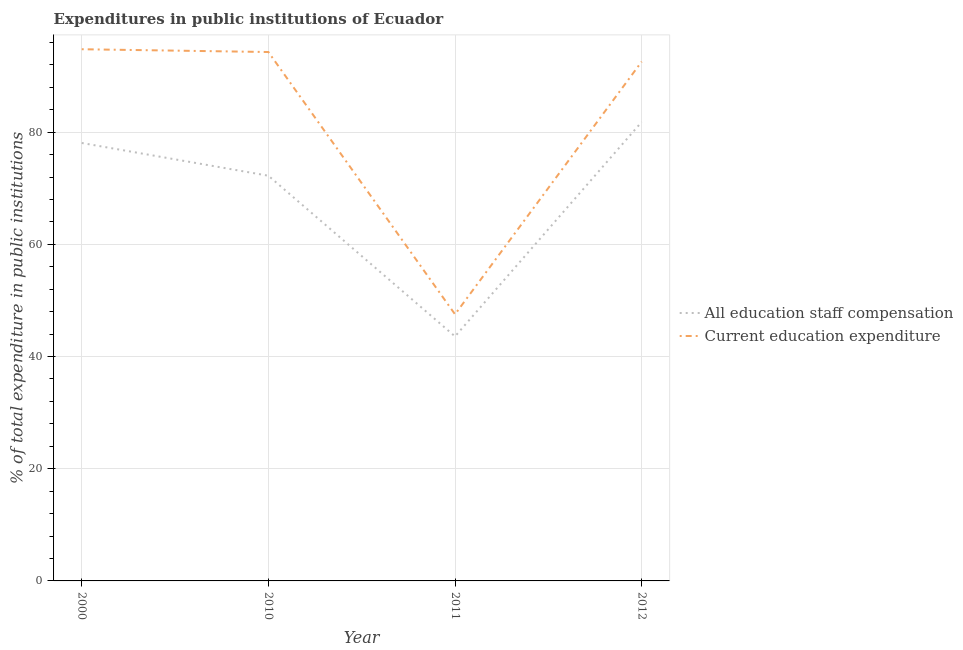Is the number of lines equal to the number of legend labels?
Ensure brevity in your answer.  Yes. What is the expenditure in education in 2000?
Provide a succinct answer. 94.78. Across all years, what is the maximum expenditure in education?
Ensure brevity in your answer.  94.78. Across all years, what is the minimum expenditure in staff compensation?
Ensure brevity in your answer.  43.59. What is the total expenditure in education in the graph?
Your answer should be compact. 329.16. What is the difference between the expenditure in education in 2000 and that in 2011?
Ensure brevity in your answer.  47.25. What is the difference between the expenditure in staff compensation in 2010 and the expenditure in education in 2011?
Your answer should be compact. 24.7. What is the average expenditure in staff compensation per year?
Offer a terse response. 68.93. In the year 2010, what is the difference between the expenditure in staff compensation and expenditure in education?
Offer a terse response. -22.05. In how many years, is the expenditure in staff compensation greater than 72 %?
Keep it short and to the point. 3. What is the ratio of the expenditure in staff compensation in 2000 to that in 2010?
Your answer should be compact. 1.08. Is the expenditure in education in 2000 less than that in 2010?
Give a very brief answer. No. What is the difference between the highest and the second highest expenditure in staff compensation?
Your answer should be very brief. 3.75. What is the difference between the highest and the lowest expenditure in education?
Ensure brevity in your answer.  47.25. In how many years, is the expenditure in staff compensation greater than the average expenditure in staff compensation taken over all years?
Provide a short and direct response. 3. Is the sum of the expenditure in education in 2000 and 2012 greater than the maximum expenditure in staff compensation across all years?
Your answer should be compact. Yes. Does the expenditure in education monotonically increase over the years?
Make the answer very short. No. Is the expenditure in staff compensation strictly greater than the expenditure in education over the years?
Your answer should be compact. No. Is the expenditure in staff compensation strictly less than the expenditure in education over the years?
Offer a terse response. Yes. What is the difference between two consecutive major ticks on the Y-axis?
Provide a succinct answer. 20. Does the graph contain any zero values?
Your response must be concise. No. Does the graph contain grids?
Give a very brief answer. Yes. How are the legend labels stacked?
Ensure brevity in your answer.  Vertical. What is the title of the graph?
Your response must be concise. Expenditures in public institutions of Ecuador. Does "Private credit bureau" appear as one of the legend labels in the graph?
Make the answer very short. No. What is the label or title of the X-axis?
Provide a succinct answer. Year. What is the label or title of the Y-axis?
Provide a short and direct response. % of total expenditure in public institutions. What is the % of total expenditure in public institutions of All education staff compensation in 2000?
Make the answer very short. 78.07. What is the % of total expenditure in public institutions in Current education expenditure in 2000?
Make the answer very short. 94.78. What is the % of total expenditure in public institutions of All education staff compensation in 2010?
Make the answer very short. 72.23. What is the % of total expenditure in public institutions in Current education expenditure in 2010?
Provide a succinct answer. 94.28. What is the % of total expenditure in public institutions in All education staff compensation in 2011?
Your answer should be very brief. 43.59. What is the % of total expenditure in public institutions of Current education expenditure in 2011?
Make the answer very short. 47.53. What is the % of total expenditure in public institutions in All education staff compensation in 2012?
Offer a very short reply. 81.82. What is the % of total expenditure in public institutions of Current education expenditure in 2012?
Your answer should be very brief. 92.57. Across all years, what is the maximum % of total expenditure in public institutions of All education staff compensation?
Your answer should be very brief. 81.82. Across all years, what is the maximum % of total expenditure in public institutions in Current education expenditure?
Give a very brief answer. 94.78. Across all years, what is the minimum % of total expenditure in public institutions of All education staff compensation?
Ensure brevity in your answer.  43.59. Across all years, what is the minimum % of total expenditure in public institutions of Current education expenditure?
Your answer should be very brief. 47.53. What is the total % of total expenditure in public institutions in All education staff compensation in the graph?
Provide a succinct answer. 275.71. What is the total % of total expenditure in public institutions in Current education expenditure in the graph?
Your answer should be compact. 329.16. What is the difference between the % of total expenditure in public institutions of All education staff compensation in 2000 and that in 2010?
Offer a terse response. 5.84. What is the difference between the % of total expenditure in public institutions of Current education expenditure in 2000 and that in 2010?
Provide a short and direct response. 0.5. What is the difference between the % of total expenditure in public institutions of All education staff compensation in 2000 and that in 2011?
Make the answer very short. 34.48. What is the difference between the % of total expenditure in public institutions of Current education expenditure in 2000 and that in 2011?
Ensure brevity in your answer.  47.25. What is the difference between the % of total expenditure in public institutions in All education staff compensation in 2000 and that in 2012?
Give a very brief answer. -3.75. What is the difference between the % of total expenditure in public institutions of Current education expenditure in 2000 and that in 2012?
Make the answer very short. 2.21. What is the difference between the % of total expenditure in public institutions of All education staff compensation in 2010 and that in 2011?
Provide a short and direct response. 28.64. What is the difference between the % of total expenditure in public institutions of Current education expenditure in 2010 and that in 2011?
Give a very brief answer. 46.75. What is the difference between the % of total expenditure in public institutions in All education staff compensation in 2010 and that in 2012?
Your response must be concise. -9.58. What is the difference between the % of total expenditure in public institutions of Current education expenditure in 2010 and that in 2012?
Ensure brevity in your answer.  1.71. What is the difference between the % of total expenditure in public institutions in All education staff compensation in 2011 and that in 2012?
Your answer should be compact. -38.23. What is the difference between the % of total expenditure in public institutions of Current education expenditure in 2011 and that in 2012?
Give a very brief answer. -45.04. What is the difference between the % of total expenditure in public institutions in All education staff compensation in 2000 and the % of total expenditure in public institutions in Current education expenditure in 2010?
Make the answer very short. -16.21. What is the difference between the % of total expenditure in public institutions in All education staff compensation in 2000 and the % of total expenditure in public institutions in Current education expenditure in 2011?
Provide a short and direct response. 30.54. What is the difference between the % of total expenditure in public institutions in All education staff compensation in 2000 and the % of total expenditure in public institutions in Current education expenditure in 2012?
Offer a terse response. -14.5. What is the difference between the % of total expenditure in public institutions in All education staff compensation in 2010 and the % of total expenditure in public institutions in Current education expenditure in 2011?
Your answer should be compact. 24.7. What is the difference between the % of total expenditure in public institutions in All education staff compensation in 2010 and the % of total expenditure in public institutions in Current education expenditure in 2012?
Your answer should be very brief. -20.34. What is the difference between the % of total expenditure in public institutions of All education staff compensation in 2011 and the % of total expenditure in public institutions of Current education expenditure in 2012?
Offer a very short reply. -48.98. What is the average % of total expenditure in public institutions in All education staff compensation per year?
Keep it short and to the point. 68.93. What is the average % of total expenditure in public institutions in Current education expenditure per year?
Offer a very short reply. 82.29. In the year 2000, what is the difference between the % of total expenditure in public institutions of All education staff compensation and % of total expenditure in public institutions of Current education expenditure?
Your answer should be very brief. -16.71. In the year 2010, what is the difference between the % of total expenditure in public institutions in All education staff compensation and % of total expenditure in public institutions in Current education expenditure?
Offer a terse response. -22.05. In the year 2011, what is the difference between the % of total expenditure in public institutions of All education staff compensation and % of total expenditure in public institutions of Current education expenditure?
Make the answer very short. -3.94. In the year 2012, what is the difference between the % of total expenditure in public institutions in All education staff compensation and % of total expenditure in public institutions in Current education expenditure?
Provide a short and direct response. -10.75. What is the ratio of the % of total expenditure in public institutions in All education staff compensation in 2000 to that in 2010?
Offer a very short reply. 1.08. What is the ratio of the % of total expenditure in public institutions of Current education expenditure in 2000 to that in 2010?
Your answer should be compact. 1.01. What is the ratio of the % of total expenditure in public institutions of All education staff compensation in 2000 to that in 2011?
Offer a very short reply. 1.79. What is the ratio of the % of total expenditure in public institutions of Current education expenditure in 2000 to that in 2011?
Offer a terse response. 1.99. What is the ratio of the % of total expenditure in public institutions in All education staff compensation in 2000 to that in 2012?
Give a very brief answer. 0.95. What is the ratio of the % of total expenditure in public institutions in Current education expenditure in 2000 to that in 2012?
Your answer should be compact. 1.02. What is the ratio of the % of total expenditure in public institutions of All education staff compensation in 2010 to that in 2011?
Give a very brief answer. 1.66. What is the ratio of the % of total expenditure in public institutions of Current education expenditure in 2010 to that in 2011?
Your answer should be very brief. 1.98. What is the ratio of the % of total expenditure in public institutions in All education staff compensation in 2010 to that in 2012?
Make the answer very short. 0.88. What is the ratio of the % of total expenditure in public institutions in Current education expenditure in 2010 to that in 2012?
Your response must be concise. 1.02. What is the ratio of the % of total expenditure in public institutions in All education staff compensation in 2011 to that in 2012?
Make the answer very short. 0.53. What is the ratio of the % of total expenditure in public institutions in Current education expenditure in 2011 to that in 2012?
Your answer should be compact. 0.51. What is the difference between the highest and the second highest % of total expenditure in public institutions of All education staff compensation?
Your answer should be very brief. 3.75. What is the difference between the highest and the second highest % of total expenditure in public institutions in Current education expenditure?
Keep it short and to the point. 0.5. What is the difference between the highest and the lowest % of total expenditure in public institutions in All education staff compensation?
Offer a very short reply. 38.23. What is the difference between the highest and the lowest % of total expenditure in public institutions of Current education expenditure?
Offer a very short reply. 47.25. 